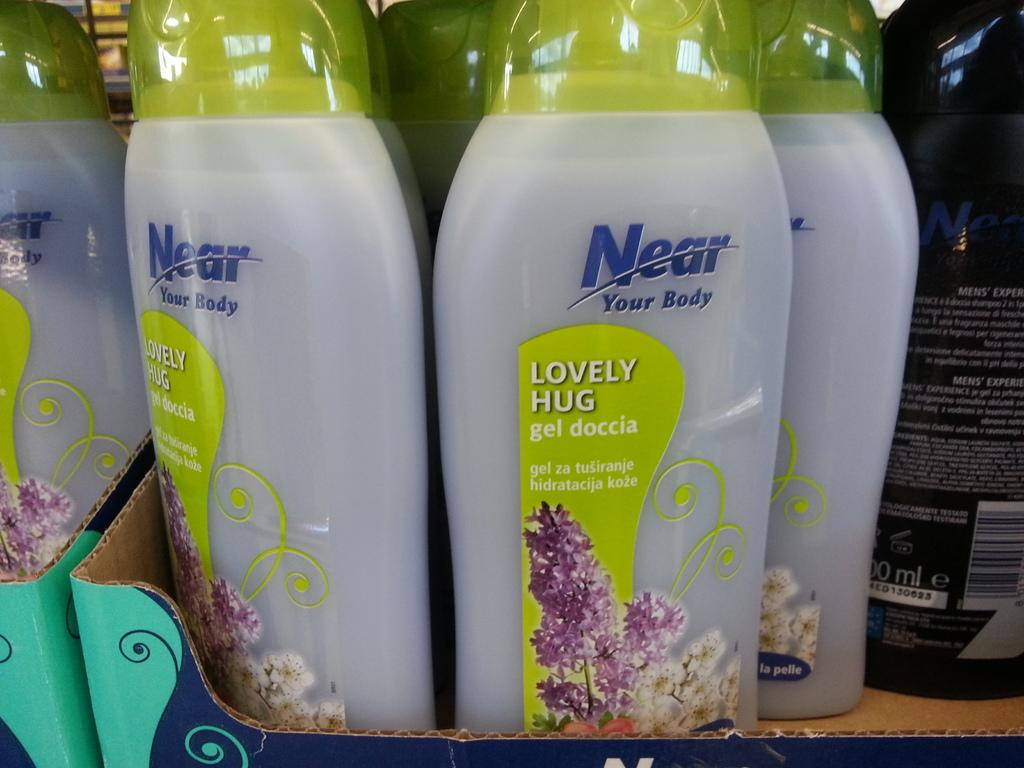<image>
Relay a brief, clear account of the picture shown. A box display of Near Your Body soap with lavender on the label. 